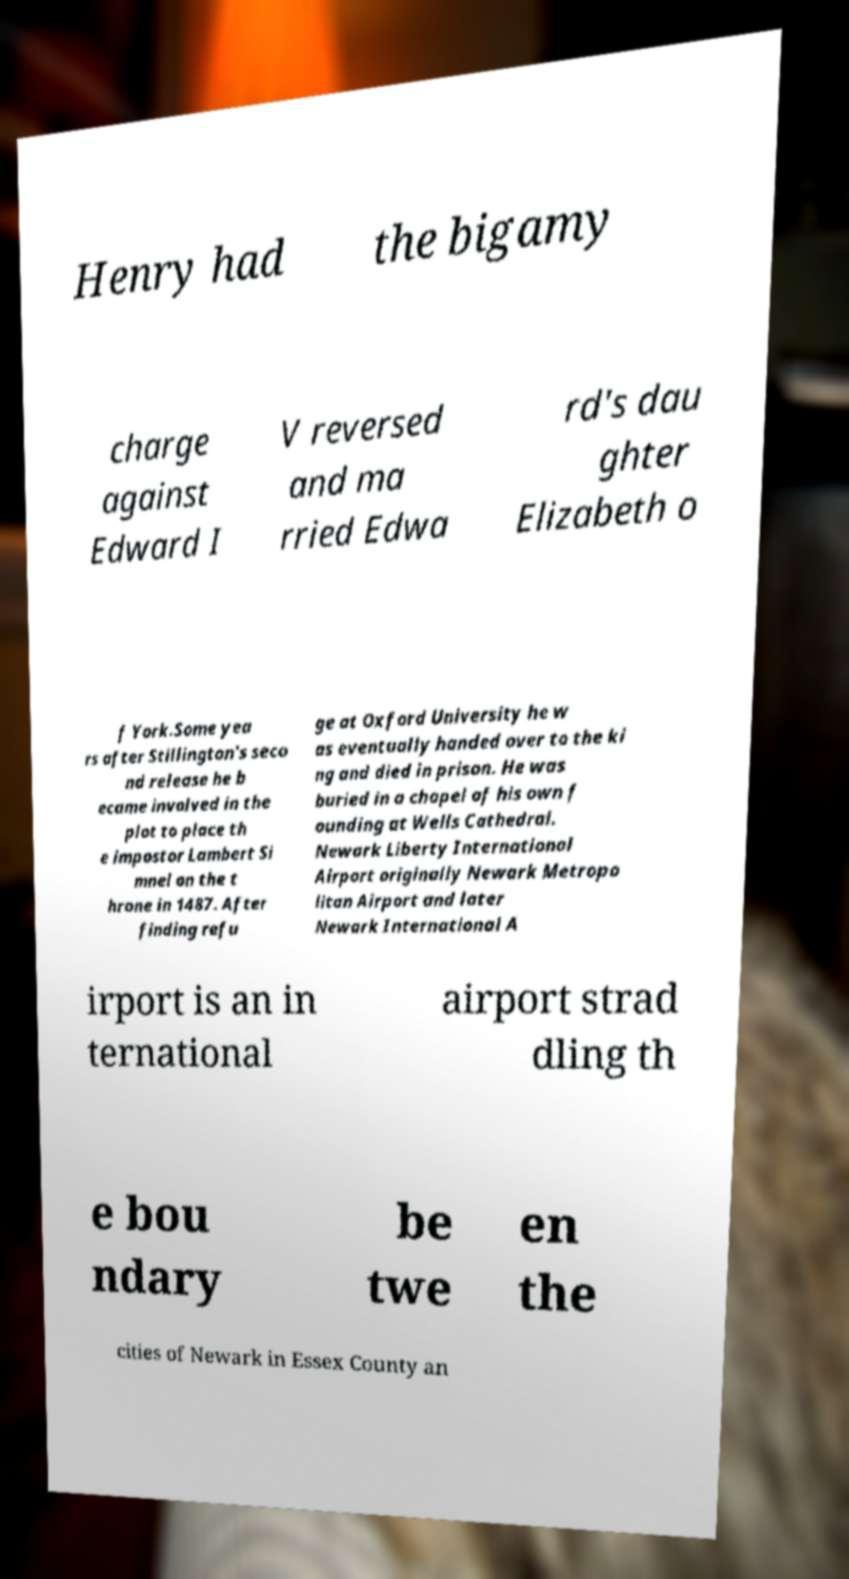For documentation purposes, I need the text within this image transcribed. Could you provide that? Henry had the bigamy charge against Edward I V reversed and ma rried Edwa rd's dau ghter Elizabeth o f York.Some yea rs after Stillington's seco nd release he b ecame involved in the plot to place th e impostor Lambert Si mnel on the t hrone in 1487. After finding refu ge at Oxford University he w as eventually handed over to the ki ng and died in prison. He was buried in a chapel of his own f ounding at Wells Cathedral. Newark Liberty International Airport originally Newark Metropo litan Airport and later Newark International A irport is an in ternational airport strad dling th e bou ndary be twe en the cities of Newark in Essex County an 